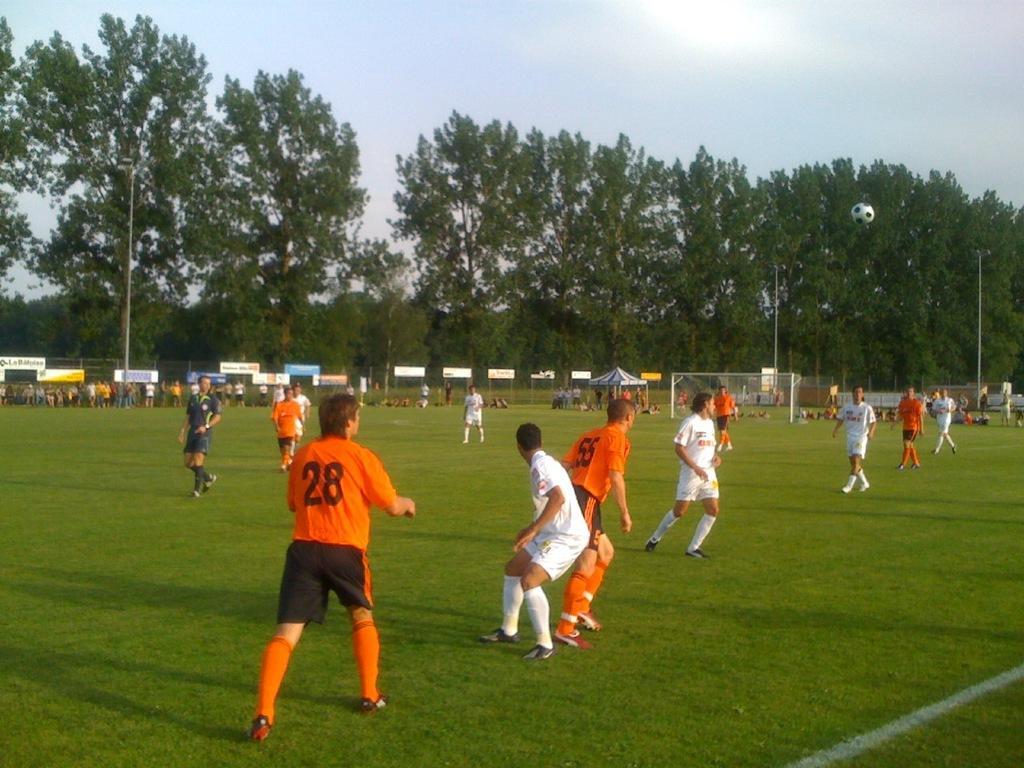Can you describe this image briefly? This image consists of many players playing in the ground. At the bottom, there is green grass. In the background, there are banners along with a fencing. And there are trees. At the top, there is a sky. 